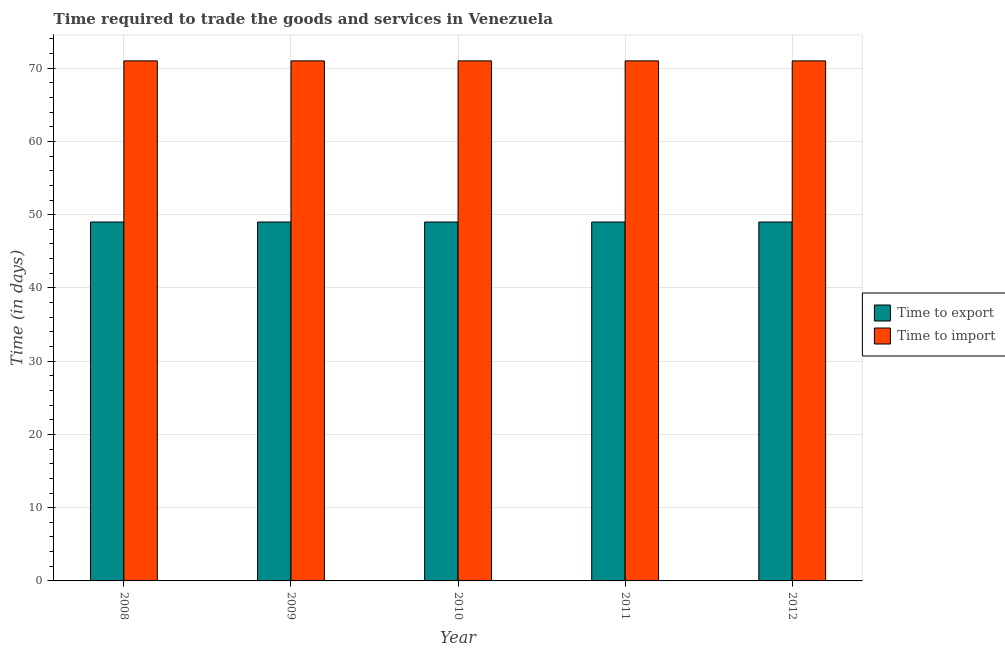How many groups of bars are there?
Make the answer very short. 5. Are the number of bars per tick equal to the number of legend labels?
Keep it short and to the point. Yes. How many bars are there on the 1st tick from the right?
Ensure brevity in your answer.  2. What is the label of the 5th group of bars from the left?
Provide a short and direct response. 2012. What is the time to export in 2012?
Ensure brevity in your answer.  49. Across all years, what is the maximum time to import?
Your response must be concise. 71. Across all years, what is the minimum time to import?
Ensure brevity in your answer.  71. In which year was the time to import maximum?
Ensure brevity in your answer.  2008. What is the total time to export in the graph?
Your answer should be compact. 245. In the year 2009, what is the difference between the time to import and time to export?
Your response must be concise. 0. In how many years, is the time to import greater than 48 days?
Provide a succinct answer. 5. What is the ratio of the time to export in 2009 to that in 2010?
Keep it short and to the point. 1. Is the time to import in 2008 less than that in 2012?
Ensure brevity in your answer.  No. Is the difference between the time to import in 2008 and 2012 greater than the difference between the time to export in 2008 and 2012?
Provide a short and direct response. No. What is the difference between the highest and the lowest time to export?
Your answer should be very brief. 0. What does the 1st bar from the left in 2012 represents?
Ensure brevity in your answer.  Time to export. What does the 1st bar from the right in 2009 represents?
Offer a very short reply. Time to import. How many bars are there?
Your answer should be very brief. 10. Are all the bars in the graph horizontal?
Offer a very short reply. No. What is the difference between two consecutive major ticks on the Y-axis?
Provide a succinct answer. 10. Are the values on the major ticks of Y-axis written in scientific E-notation?
Give a very brief answer. No. Does the graph contain any zero values?
Offer a very short reply. No. Where does the legend appear in the graph?
Keep it short and to the point. Center right. How many legend labels are there?
Ensure brevity in your answer.  2. What is the title of the graph?
Your answer should be compact. Time required to trade the goods and services in Venezuela. What is the label or title of the X-axis?
Offer a terse response. Year. What is the label or title of the Y-axis?
Your answer should be compact. Time (in days). What is the Time (in days) of Time to export in 2008?
Offer a very short reply. 49. What is the Time (in days) of Time to export in 2009?
Keep it short and to the point. 49. What is the Time (in days) of Time to export in 2010?
Your answer should be very brief. 49. What is the Time (in days) of Time to import in 2010?
Provide a short and direct response. 71. What is the Time (in days) in Time to export in 2012?
Keep it short and to the point. 49. What is the Time (in days) in Time to import in 2012?
Provide a short and direct response. 71. Across all years, what is the maximum Time (in days) of Time to import?
Your answer should be very brief. 71. What is the total Time (in days) of Time to export in the graph?
Make the answer very short. 245. What is the total Time (in days) of Time to import in the graph?
Keep it short and to the point. 355. What is the difference between the Time (in days) in Time to export in 2008 and that in 2009?
Give a very brief answer. 0. What is the difference between the Time (in days) in Time to import in 2008 and that in 2009?
Provide a succinct answer. 0. What is the difference between the Time (in days) of Time to export in 2008 and that in 2011?
Keep it short and to the point. 0. What is the difference between the Time (in days) in Time to export in 2008 and that in 2012?
Your answer should be compact. 0. What is the difference between the Time (in days) in Time to import in 2008 and that in 2012?
Your response must be concise. 0. What is the difference between the Time (in days) in Time to export in 2010 and that in 2011?
Offer a terse response. 0. What is the difference between the Time (in days) in Time to import in 2010 and that in 2011?
Provide a short and direct response. 0. What is the difference between the Time (in days) in Time to export in 2010 and that in 2012?
Provide a succinct answer. 0. What is the difference between the Time (in days) in Time to import in 2010 and that in 2012?
Offer a very short reply. 0. What is the difference between the Time (in days) of Time to export in 2011 and that in 2012?
Provide a short and direct response. 0. What is the difference between the Time (in days) in Time to export in 2008 and the Time (in days) in Time to import in 2009?
Provide a succinct answer. -22. What is the difference between the Time (in days) of Time to export in 2008 and the Time (in days) of Time to import in 2011?
Your response must be concise. -22. What is the difference between the Time (in days) in Time to export in 2009 and the Time (in days) in Time to import in 2011?
Make the answer very short. -22. What is the difference between the Time (in days) of Time to export in 2009 and the Time (in days) of Time to import in 2012?
Keep it short and to the point. -22. What is the difference between the Time (in days) in Time to export in 2010 and the Time (in days) in Time to import in 2011?
Give a very brief answer. -22. What is the difference between the Time (in days) in Time to export in 2010 and the Time (in days) in Time to import in 2012?
Give a very brief answer. -22. What is the difference between the Time (in days) in Time to export in 2011 and the Time (in days) in Time to import in 2012?
Offer a terse response. -22. What is the average Time (in days) in Time to export per year?
Provide a succinct answer. 49. What is the average Time (in days) of Time to import per year?
Provide a succinct answer. 71. In the year 2008, what is the difference between the Time (in days) in Time to export and Time (in days) in Time to import?
Your answer should be compact. -22. In the year 2009, what is the difference between the Time (in days) of Time to export and Time (in days) of Time to import?
Provide a short and direct response. -22. In the year 2012, what is the difference between the Time (in days) of Time to export and Time (in days) of Time to import?
Offer a terse response. -22. What is the ratio of the Time (in days) in Time to import in 2008 to that in 2009?
Provide a succinct answer. 1. What is the ratio of the Time (in days) in Time to export in 2008 to that in 2010?
Make the answer very short. 1. What is the ratio of the Time (in days) in Time to export in 2008 to that in 2011?
Your answer should be compact. 1. What is the ratio of the Time (in days) of Time to import in 2009 to that in 2012?
Keep it short and to the point. 1. What is the ratio of the Time (in days) of Time to export in 2010 to that in 2011?
Make the answer very short. 1. What is the ratio of the Time (in days) of Time to export in 2010 to that in 2012?
Give a very brief answer. 1. What is the ratio of the Time (in days) in Time to import in 2010 to that in 2012?
Keep it short and to the point. 1. What is the difference between the highest and the second highest Time (in days) of Time to export?
Provide a succinct answer. 0. What is the difference between the highest and the second highest Time (in days) in Time to import?
Provide a succinct answer. 0. 